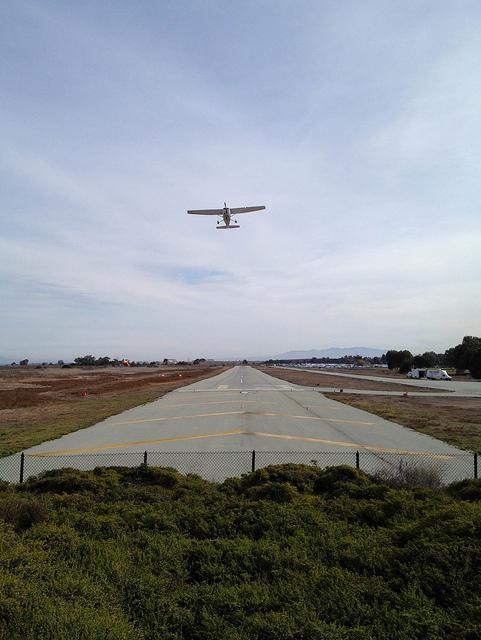What is the plane pictured above doing?
Indicate the correct choice and explain in the format: 'Answer: answer
Rationale: rationale.'
Options: Take off, stopped, landing, fuelling. Answer: take off.
Rationale: When planes are landing, their noses are tipped downward. the nose of this plane is tipped up, indicating it is headed into the sky. 